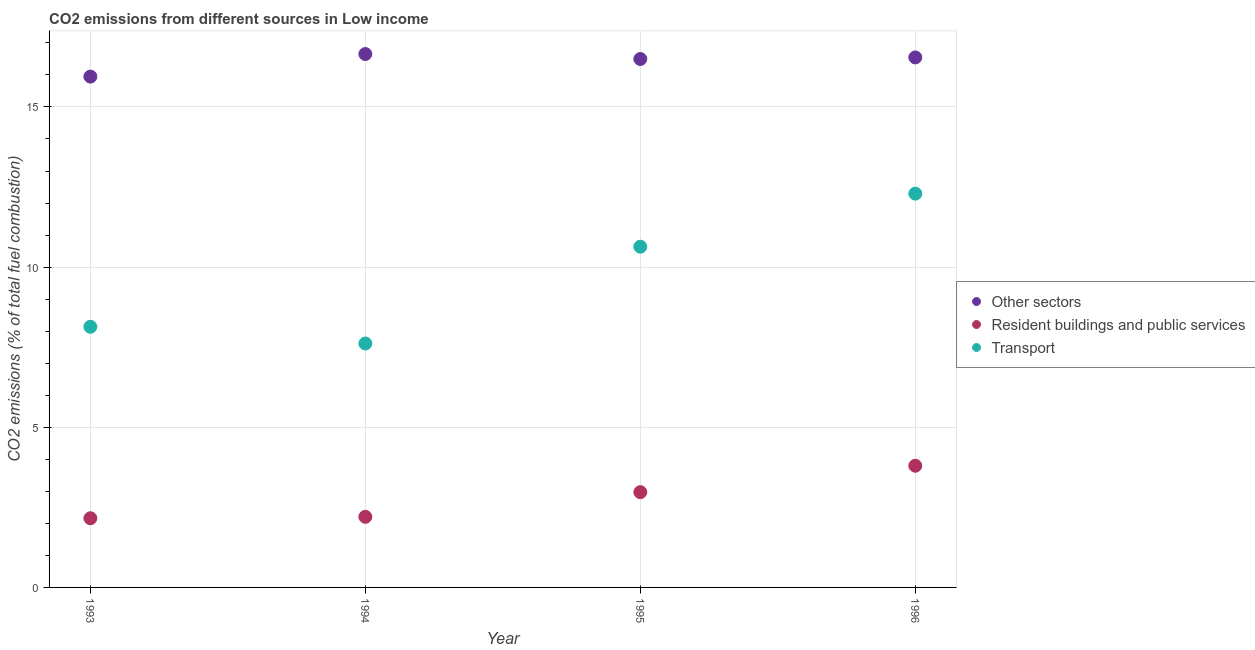Is the number of dotlines equal to the number of legend labels?
Your answer should be compact. Yes. What is the percentage of co2 emissions from transport in 1994?
Offer a very short reply. 7.62. Across all years, what is the maximum percentage of co2 emissions from transport?
Your response must be concise. 12.29. Across all years, what is the minimum percentage of co2 emissions from other sectors?
Provide a succinct answer. 15.95. In which year was the percentage of co2 emissions from transport minimum?
Your response must be concise. 1994. What is the total percentage of co2 emissions from other sectors in the graph?
Offer a very short reply. 65.65. What is the difference between the percentage of co2 emissions from resident buildings and public services in 1993 and that in 1996?
Ensure brevity in your answer.  -1.64. What is the difference between the percentage of co2 emissions from transport in 1996 and the percentage of co2 emissions from other sectors in 1995?
Provide a short and direct response. -4.2. What is the average percentage of co2 emissions from resident buildings and public services per year?
Give a very brief answer. 2.78. In the year 1995, what is the difference between the percentage of co2 emissions from resident buildings and public services and percentage of co2 emissions from other sectors?
Provide a short and direct response. -13.52. In how many years, is the percentage of co2 emissions from other sectors greater than 4 %?
Provide a short and direct response. 4. What is the ratio of the percentage of co2 emissions from other sectors in 1993 to that in 1995?
Offer a very short reply. 0.97. What is the difference between the highest and the second highest percentage of co2 emissions from other sectors?
Your answer should be very brief. 0.11. What is the difference between the highest and the lowest percentage of co2 emissions from transport?
Ensure brevity in your answer.  4.68. In how many years, is the percentage of co2 emissions from resident buildings and public services greater than the average percentage of co2 emissions from resident buildings and public services taken over all years?
Give a very brief answer. 2. How many dotlines are there?
Your response must be concise. 3. Are the values on the major ticks of Y-axis written in scientific E-notation?
Your answer should be compact. No. Does the graph contain grids?
Ensure brevity in your answer.  Yes. How many legend labels are there?
Offer a very short reply. 3. What is the title of the graph?
Offer a terse response. CO2 emissions from different sources in Low income. What is the label or title of the Y-axis?
Offer a very short reply. CO2 emissions (% of total fuel combustion). What is the CO2 emissions (% of total fuel combustion) in Other sectors in 1993?
Provide a short and direct response. 15.95. What is the CO2 emissions (% of total fuel combustion) of Resident buildings and public services in 1993?
Make the answer very short. 2.16. What is the CO2 emissions (% of total fuel combustion) of Transport in 1993?
Give a very brief answer. 8.14. What is the CO2 emissions (% of total fuel combustion) in Other sectors in 1994?
Provide a short and direct response. 16.65. What is the CO2 emissions (% of total fuel combustion) of Resident buildings and public services in 1994?
Make the answer very short. 2.2. What is the CO2 emissions (% of total fuel combustion) of Transport in 1994?
Your answer should be very brief. 7.62. What is the CO2 emissions (% of total fuel combustion) of Other sectors in 1995?
Provide a succinct answer. 16.5. What is the CO2 emissions (% of total fuel combustion) in Resident buildings and public services in 1995?
Offer a very short reply. 2.97. What is the CO2 emissions (% of total fuel combustion) in Transport in 1995?
Offer a very short reply. 10.64. What is the CO2 emissions (% of total fuel combustion) of Other sectors in 1996?
Ensure brevity in your answer.  16.55. What is the CO2 emissions (% of total fuel combustion) of Resident buildings and public services in 1996?
Your answer should be compact. 3.8. What is the CO2 emissions (% of total fuel combustion) in Transport in 1996?
Your response must be concise. 12.29. Across all years, what is the maximum CO2 emissions (% of total fuel combustion) of Other sectors?
Keep it short and to the point. 16.65. Across all years, what is the maximum CO2 emissions (% of total fuel combustion) in Resident buildings and public services?
Your response must be concise. 3.8. Across all years, what is the maximum CO2 emissions (% of total fuel combustion) of Transport?
Offer a terse response. 12.29. Across all years, what is the minimum CO2 emissions (% of total fuel combustion) in Other sectors?
Give a very brief answer. 15.95. Across all years, what is the minimum CO2 emissions (% of total fuel combustion) of Resident buildings and public services?
Your answer should be compact. 2.16. Across all years, what is the minimum CO2 emissions (% of total fuel combustion) of Transport?
Offer a terse response. 7.62. What is the total CO2 emissions (% of total fuel combustion) of Other sectors in the graph?
Offer a terse response. 65.65. What is the total CO2 emissions (% of total fuel combustion) in Resident buildings and public services in the graph?
Your response must be concise. 11.14. What is the total CO2 emissions (% of total fuel combustion) in Transport in the graph?
Your answer should be very brief. 38.68. What is the difference between the CO2 emissions (% of total fuel combustion) in Other sectors in 1993 and that in 1994?
Your answer should be compact. -0.7. What is the difference between the CO2 emissions (% of total fuel combustion) in Resident buildings and public services in 1993 and that in 1994?
Provide a succinct answer. -0.04. What is the difference between the CO2 emissions (% of total fuel combustion) in Transport in 1993 and that in 1994?
Give a very brief answer. 0.52. What is the difference between the CO2 emissions (% of total fuel combustion) in Other sectors in 1993 and that in 1995?
Provide a short and direct response. -0.55. What is the difference between the CO2 emissions (% of total fuel combustion) in Resident buildings and public services in 1993 and that in 1995?
Provide a short and direct response. -0.81. What is the difference between the CO2 emissions (% of total fuel combustion) of Transport in 1993 and that in 1995?
Your answer should be compact. -2.5. What is the difference between the CO2 emissions (% of total fuel combustion) in Other sectors in 1993 and that in 1996?
Offer a terse response. -0.6. What is the difference between the CO2 emissions (% of total fuel combustion) in Resident buildings and public services in 1993 and that in 1996?
Your response must be concise. -1.64. What is the difference between the CO2 emissions (% of total fuel combustion) in Transport in 1993 and that in 1996?
Offer a very short reply. -4.16. What is the difference between the CO2 emissions (% of total fuel combustion) in Other sectors in 1994 and that in 1995?
Provide a succinct answer. 0.15. What is the difference between the CO2 emissions (% of total fuel combustion) in Resident buildings and public services in 1994 and that in 1995?
Provide a short and direct response. -0.77. What is the difference between the CO2 emissions (% of total fuel combustion) in Transport in 1994 and that in 1995?
Provide a succinct answer. -3.02. What is the difference between the CO2 emissions (% of total fuel combustion) in Other sectors in 1994 and that in 1996?
Your response must be concise. 0.11. What is the difference between the CO2 emissions (% of total fuel combustion) of Resident buildings and public services in 1994 and that in 1996?
Offer a terse response. -1.59. What is the difference between the CO2 emissions (% of total fuel combustion) in Transport in 1994 and that in 1996?
Your response must be concise. -4.68. What is the difference between the CO2 emissions (% of total fuel combustion) in Other sectors in 1995 and that in 1996?
Your response must be concise. -0.05. What is the difference between the CO2 emissions (% of total fuel combustion) of Resident buildings and public services in 1995 and that in 1996?
Provide a succinct answer. -0.83. What is the difference between the CO2 emissions (% of total fuel combustion) in Transport in 1995 and that in 1996?
Ensure brevity in your answer.  -1.66. What is the difference between the CO2 emissions (% of total fuel combustion) of Other sectors in 1993 and the CO2 emissions (% of total fuel combustion) of Resident buildings and public services in 1994?
Provide a succinct answer. 13.74. What is the difference between the CO2 emissions (% of total fuel combustion) of Other sectors in 1993 and the CO2 emissions (% of total fuel combustion) of Transport in 1994?
Provide a short and direct response. 8.33. What is the difference between the CO2 emissions (% of total fuel combustion) of Resident buildings and public services in 1993 and the CO2 emissions (% of total fuel combustion) of Transport in 1994?
Provide a succinct answer. -5.46. What is the difference between the CO2 emissions (% of total fuel combustion) of Other sectors in 1993 and the CO2 emissions (% of total fuel combustion) of Resident buildings and public services in 1995?
Your response must be concise. 12.97. What is the difference between the CO2 emissions (% of total fuel combustion) of Other sectors in 1993 and the CO2 emissions (% of total fuel combustion) of Transport in 1995?
Give a very brief answer. 5.31. What is the difference between the CO2 emissions (% of total fuel combustion) of Resident buildings and public services in 1993 and the CO2 emissions (% of total fuel combustion) of Transport in 1995?
Offer a very short reply. -8.48. What is the difference between the CO2 emissions (% of total fuel combustion) of Other sectors in 1993 and the CO2 emissions (% of total fuel combustion) of Resident buildings and public services in 1996?
Provide a short and direct response. 12.15. What is the difference between the CO2 emissions (% of total fuel combustion) in Other sectors in 1993 and the CO2 emissions (% of total fuel combustion) in Transport in 1996?
Provide a succinct answer. 3.65. What is the difference between the CO2 emissions (% of total fuel combustion) in Resident buildings and public services in 1993 and the CO2 emissions (% of total fuel combustion) in Transport in 1996?
Your response must be concise. -10.13. What is the difference between the CO2 emissions (% of total fuel combustion) of Other sectors in 1994 and the CO2 emissions (% of total fuel combustion) of Resident buildings and public services in 1995?
Your answer should be very brief. 13.68. What is the difference between the CO2 emissions (% of total fuel combustion) of Other sectors in 1994 and the CO2 emissions (% of total fuel combustion) of Transport in 1995?
Ensure brevity in your answer.  6.01. What is the difference between the CO2 emissions (% of total fuel combustion) in Resident buildings and public services in 1994 and the CO2 emissions (% of total fuel combustion) in Transport in 1995?
Offer a terse response. -8.43. What is the difference between the CO2 emissions (% of total fuel combustion) in Other sectors in 1994 and the CO2 emissions (% of total fuel combustion) in Resident buildings and public services in 1996?
Provide a short and direct response. 12.85. What is the difference between the CO2 emissions (% of total fuel combustion) in Other sectors in 1994 and the CO2 emissions (% of total fuel combustion) in Transport in 1996?
Give a very brief answer. 4.36. What is the difference between the CO2 emissions (% of total fuel combustion) in Resident buildings and public services in 1994 and the CO2 emissions (% of total fuel combustion) in Transport in 1996?
Keep it short and to the point. -10.09. What is the difference between the CO2 emissions (% of total fuel combustion) in Other sectors in 1995 and the CO2 emissions (% of total fuel combustion) in Resident buildings and public services in 1996?
Ensure brevity in your answer.  12.7. What is the difference between the CO2 emissions (% of total fuel combustion) of Other sectors in 1995 and the CO2 emissions (% of total fuel combustion) of Transport in 1996?
Keep it short and to the point. 4.2. What is the difference between the CO2 emissions (% of total fuel combustion) in Resident buildings and public services in 1995 and the CO2 emissions (% of total fuel combustion) in Transport in 1996?
Make the answer very short. -9.32. What is the average CO2 emissions (% of total fuel combustion) of Other sectors per year?
Ensure brevity in your answer.  16.41. What is the average CO2 emissions (% of total fuel combustion) in Resident buildings and public services per year?
Your answer should be compact. 2.78. What is the average CO2 emissions (% of total fuel combustion) of Transport per year?
Provide a succinct answer. 9.67. In the year 1993, what is the difference between the CO2 emissions (% of total fuel combustion) in Other sectors and CO2 emissions (% of total fuel combustion) in Resident buildings and public services?
Offer a terse response. 13.79. In the year 1993, what is the difference between the CO2 emissions (% of total fuel combustion) of Other sectors and CO2 emissions (% of total fuel combustion) of Transport?
Make the answer very short. 7.81. In the year 1993, what is the difference between the CO2 emissions (% of total fuel combustion) of Resident buildings and public services and CO2 emissions (% of total fuel combustion) of Transport?
Provide a short and direct response. -5.98. In the year 1994, what is the difference between the CO2 emissions (% of total fuel combustion) of Other sectors and CO2 emissions (% of total fuel combustion) of Resident buildings and public services?
Your answer should be very brief. 14.45. In the year 1994, what is the difference between the CO2 emissions (% of total fuel combustion) in Other sectors and CO2 emissions (% of total fuel combustion) in Transport?
Your response must be concise. 9.04. In the year 1994, what is the difference between the CO2 emissions (% of total fuel combustion) in Resident buildings and public services and CO2 emissions (% of total fuel combustion) in Transport?
Your answer should be very brief. -5.41. In the year 1995, what is the difference between the CO2 emissions (% of total fuel combustion) in Other sectors and CO2 emissions (% of total fuel combustion) in Resident buildings and public services?
Your answer should be very brief. 13.52. In the year 1995, what is the difference between the CO2 emissions (% of total fuel combustion) in Other sectors and CO2 emissions (% of total fuel combustion) in Transport?
Ensure brevity in your answer.  5.86. In the year 1995, what is the difference between the CO2 emissions (% of total fuel combustion) of Resident buildings and public services and CO2 emissions (% of total fuel combustion) of Transport?
Offer a terse response. -7.66. In the year 1996, what is the difference between the CO2 emissions (% of total fuel combustion) of Other sectors and CO2 emissions (% of total fuel combustion) of Resident buildings and public services?
Your answer should be very brief. 12.75. In the year 1996, what is the difference between the CO2 emissions (% of total fuel combustion) in Other sectors and CO2 emissions (% of total fuel combustion) in Transport?
Your response must be concise. 4.25. In the year 1996, what is the difference between the CO2 emissions (% of total fuel combustion) of Resident buildings and public services and CO2 emissions (% of total fuel combustion) of Transport?
Provide a succinct answer. -8.5. What is the ratio of the CO2 emissions (% of total fuel combustion) of Other sectors in 1993 to that in 1994?
Offer a very short reply. 0.96. What is the ratio of the CO2 emissions (% of total fuel combustion) of Resident buildings and public services in 1993 to that in 1994?
Make the answer very short. 0.98. What is the ratio of the CO2 emissions (% of total fuel combustion) in Transport in 1993 to that in 1994?
Your answer should be compact. 1.07. What is the ratio of the CO2 emissions (% of total fuel combustion) of Other sectors in 1993 to that in 1995?
Give a very brief answer. 0.97. What is the ratio of the CO2 emissions (% of total fuel combustion) of Resident buildings and public services in 1993 to that in 1995?
Give a very brief answer. 0.73. What is the ratio of the CO2 emissions (% of total fuel combustion) in Transport in 1993 to that in 1995?
Give a very brief answer. 0.76. What is the ratio of the CO2 emissions (% of total fuel combustion) in Other sectors in 1993 to that in 1996?
Provide a succinct answer. 0.96. What is the ratio of the CO2 emissions (% of total fuel combustion) in Resident buildings and public services in 1993 to that in 1996?
Provide a short and direct response. 0.57. What is the ratio of the CO2 emissions (% of total fuel combustion) of Transport in 1993 to that in 1996?
Ensure brevity in your answer.  0.66. What is the ratio of the CO2 emissions (% of total fuel combustion) of Other sectors in 1994 to that in 1995?
Offer a very short reply. 1.01. What is the ratio of the CO2 emissions (% of total fuel combustion) of Resident buildings and public services in 1994 to that in 1995?
Keep it short and to the point. 0.74. What is the ratio of the CO2 emissions (% of total fuel combustion) in Transport in 1994 to that in 1995?
Your response must be concise. 0.72. What is the ratio of the CO2 emissions (% of total fuel combustion) of Other sectors in 1994 to that in 1996?
Provide a succinct answer. 1.01. What is the ratio of the CO2 emissions (% of total fuel combustion) in Resident buildings and public services in 1994 to that in 1996?
Keep it short and to the point. 0.58. What is the ratio of the CO2 emissions (% of total fuel combustion) in Transport in 1994 to that in 1996?
Keep it short and to the point. 0.62. What is the ratio of the CO2 emissions (% of total fuel combustion) in Resident buildings and public services in 1995 to that in 1996?
Offer a very short reply. 0.78. What is the ratio of the CO2 emissions (% of total fuel combustion) in Transport in 1995 to that in 1996?
Provide a succinct answer. 0.87. What is the difference between the highest and the second highest CO2 emissions (% of total fuel combustion) in Other sectors?
Provide a succinct answer. 0.11. What is the difference between the highest and the second highest CO2 emissions (% of total fuel combustion) of Resident buildings and public services?
Make the answer very short. 0.83. What is the difference between the highest and the second highest CO2 emissions (% of total fuel combustion) of Transport?
Make the answer very short. 1.66. What is the difference between the highest and the lowest CO2 emissions (% of total fuel combustion) of Other sectors?
Make the answer very short. 0.7. What is the difference between the highest and the lowest CO2 emissions (% of total fuel combustion) of Resident buildings and public services?
Ensure brevity in your answer.  1.64. What is the difference between the highest and the lowest CO2 emissions (% of total fuel combustion) in Transport?
Keep it short and to the point. 4.68. 